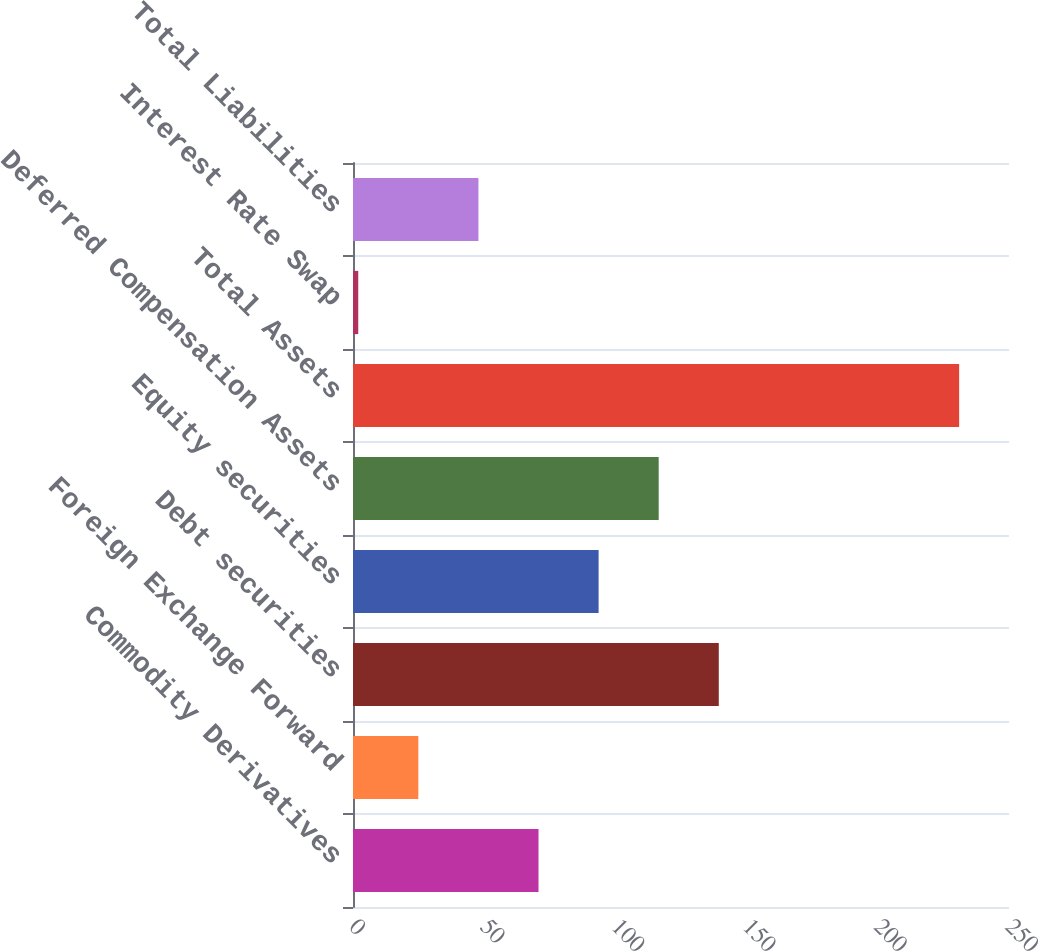<chart> <loc_0><loc_0><loc_500><loc_500><bar_chart><fcel>Commodity Derivatives<fcel>Foreign Exchange Forward<fcel>Debt securities<fcel>Equity securities<fcel>Deferred Compensation Assets<fcel>Total Assets<fcel>Interest Rate Swap<fcel>Total Liabilities<nl><fcel>70.7<fcel>24.9<fcel>139.4<fcel>93.6<fcel>116.5<fcel>231<fcel>2<fcel>47.8<nl></chart> 